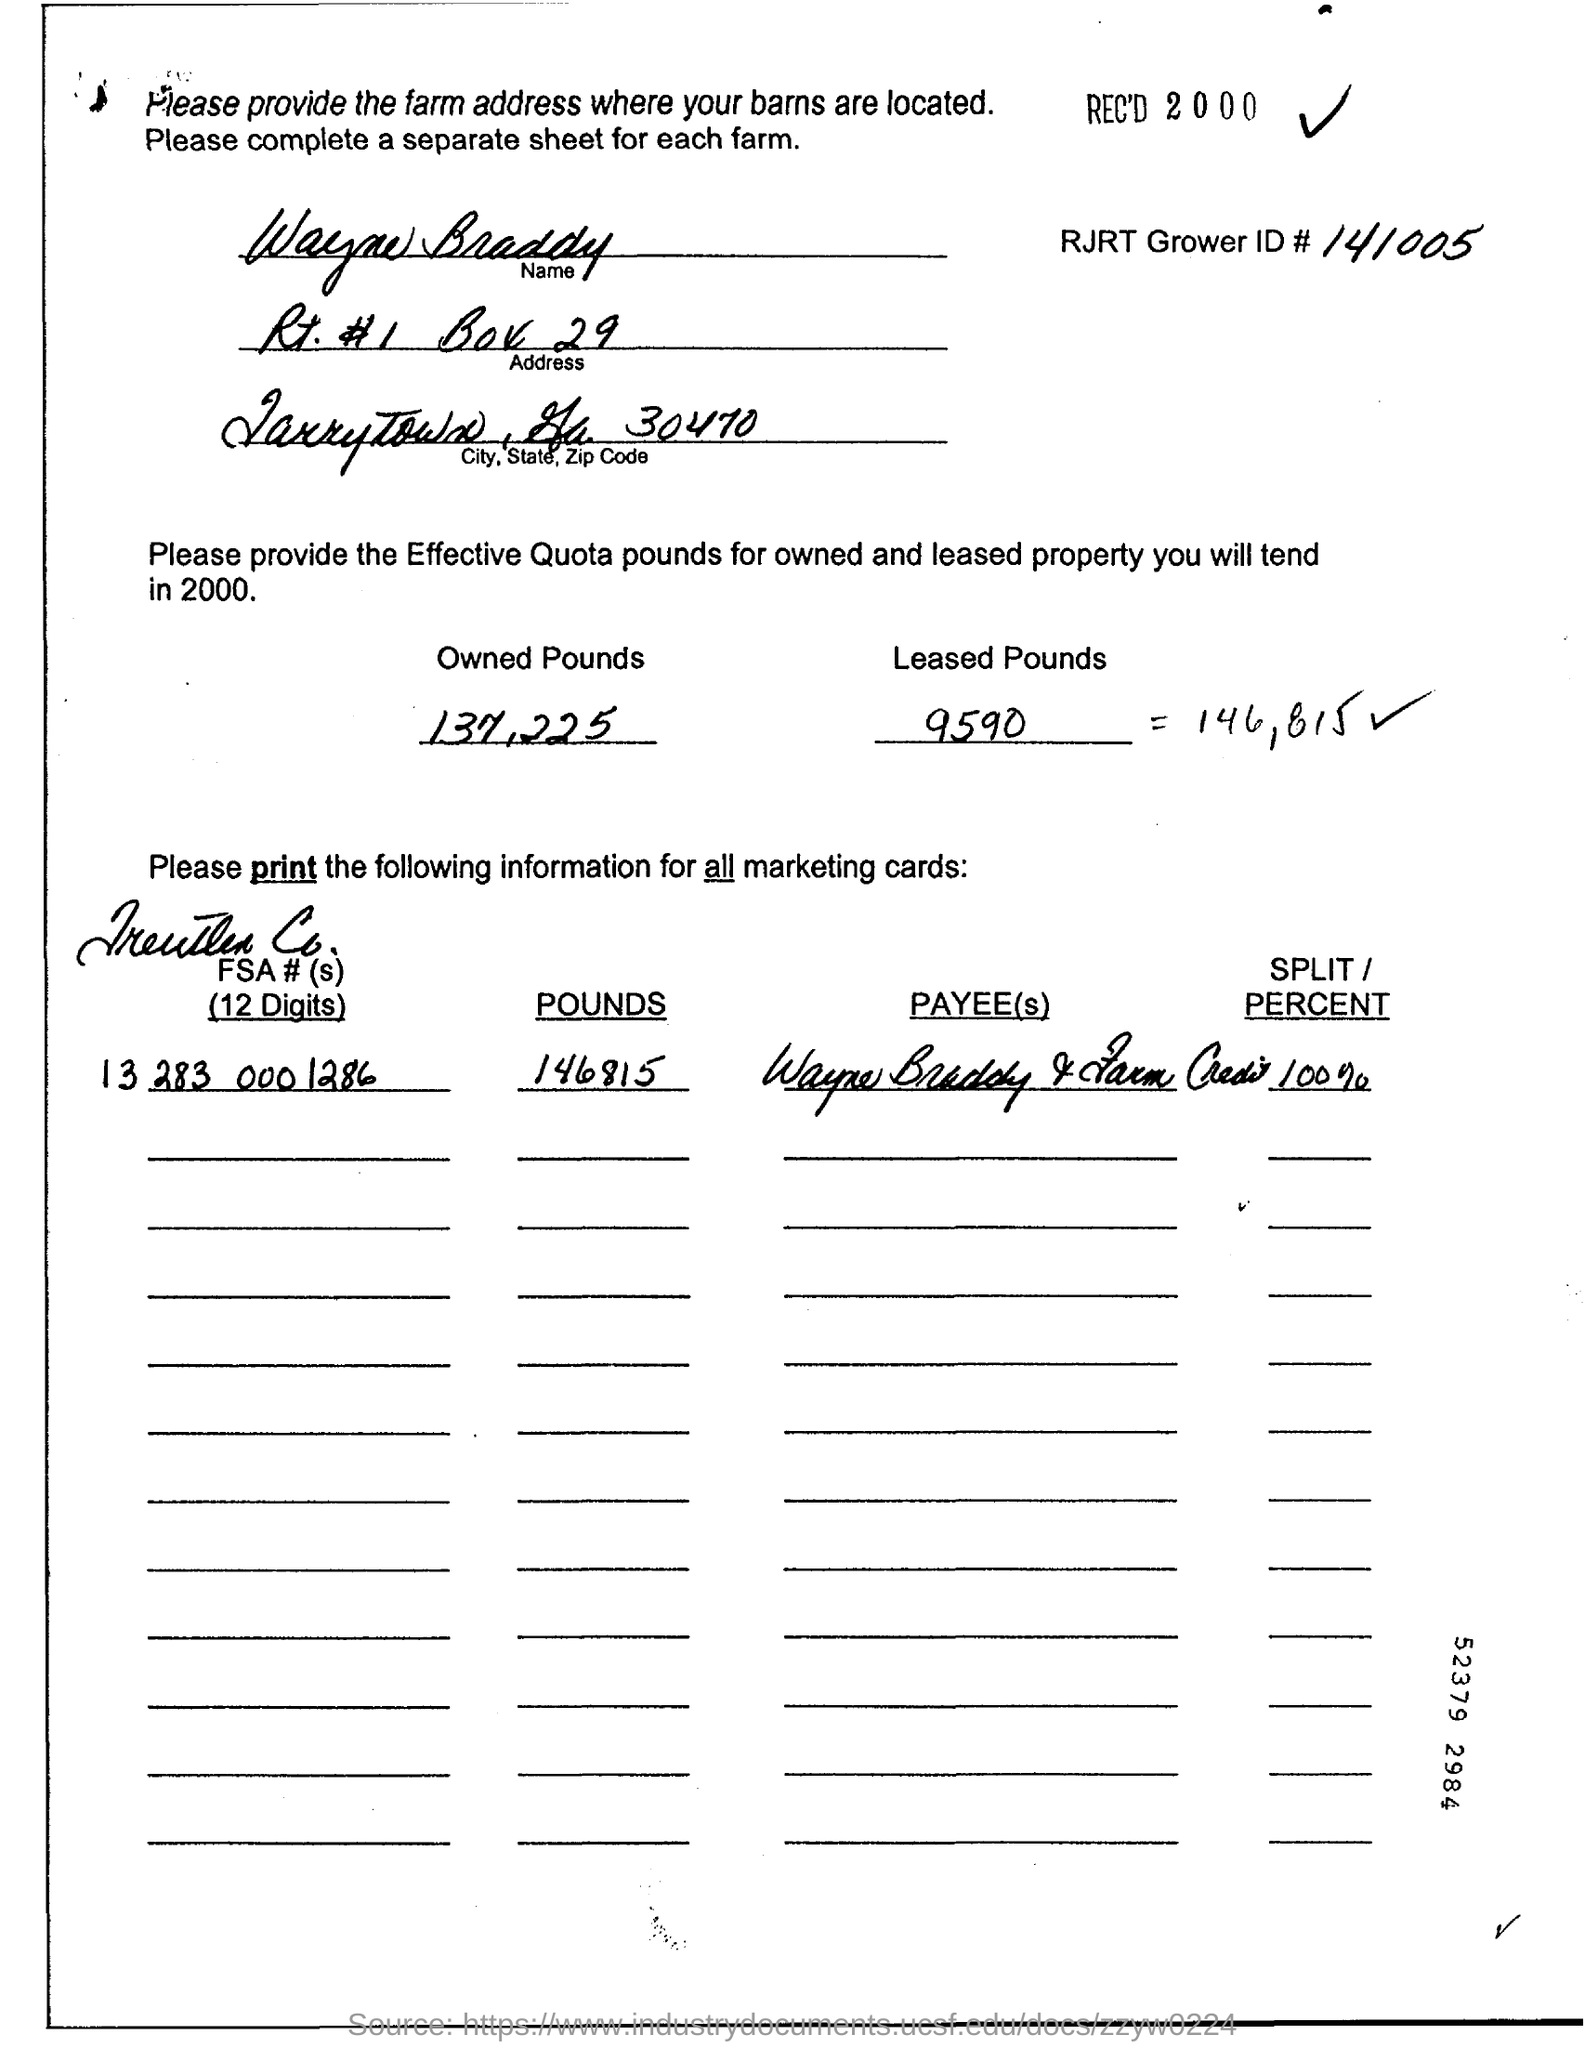Outline some significant characteristics in this image. The cost of leased pounds is 9,590. The amount of owned pounds is 137,225. 